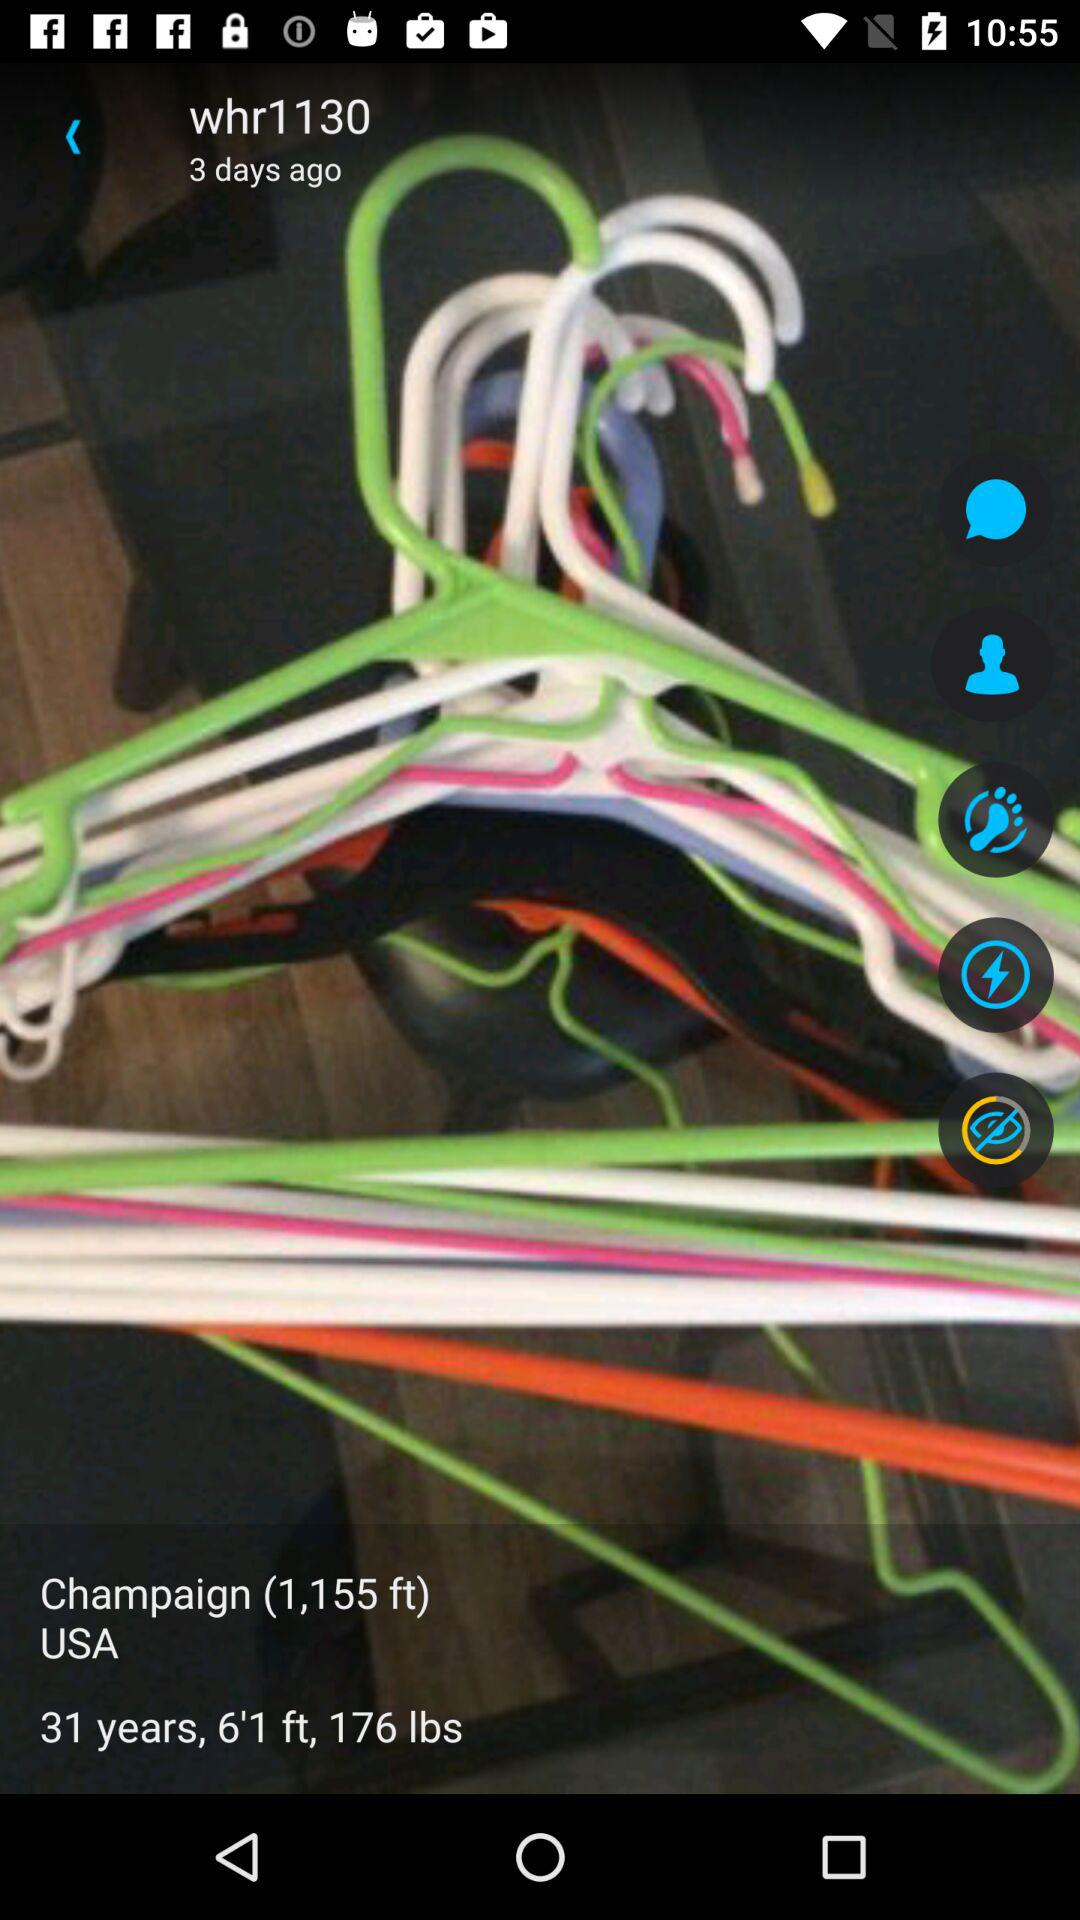In which state does the user live?
When the provided information is insufficient, respond with <no answer>. <no answer> 